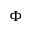Convert formula to latex. <formula><loc_0><loc_0><loc_500><loc_500>\Phi</formula> 